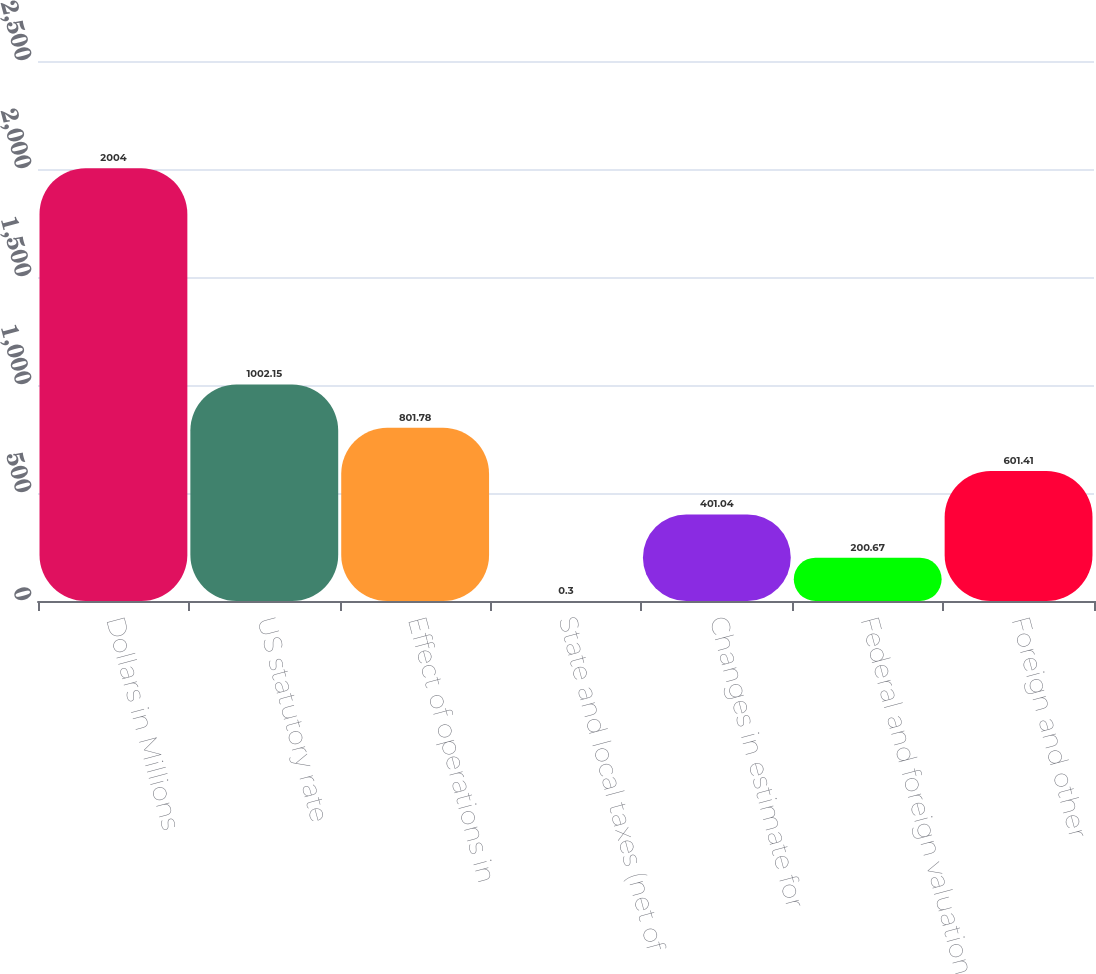Convert chart. <chart><loc_0><loc_0><loc_500><loc_500><bar_chart><fcel>Dollars in Millions<fcel>US statutory rate<fcel>Effect of operations in<fcel>State and local taxes (net of<fcel>Changes in estimate for<fcel>Federal and foreign valuation<fcel>Foreign and other<nl><fcel>2004<fcel>1002.15<fcel>801.78<fcel>0.3<fcel>401.04<fcel>200.67<fcel>601.41<nl></chart> 